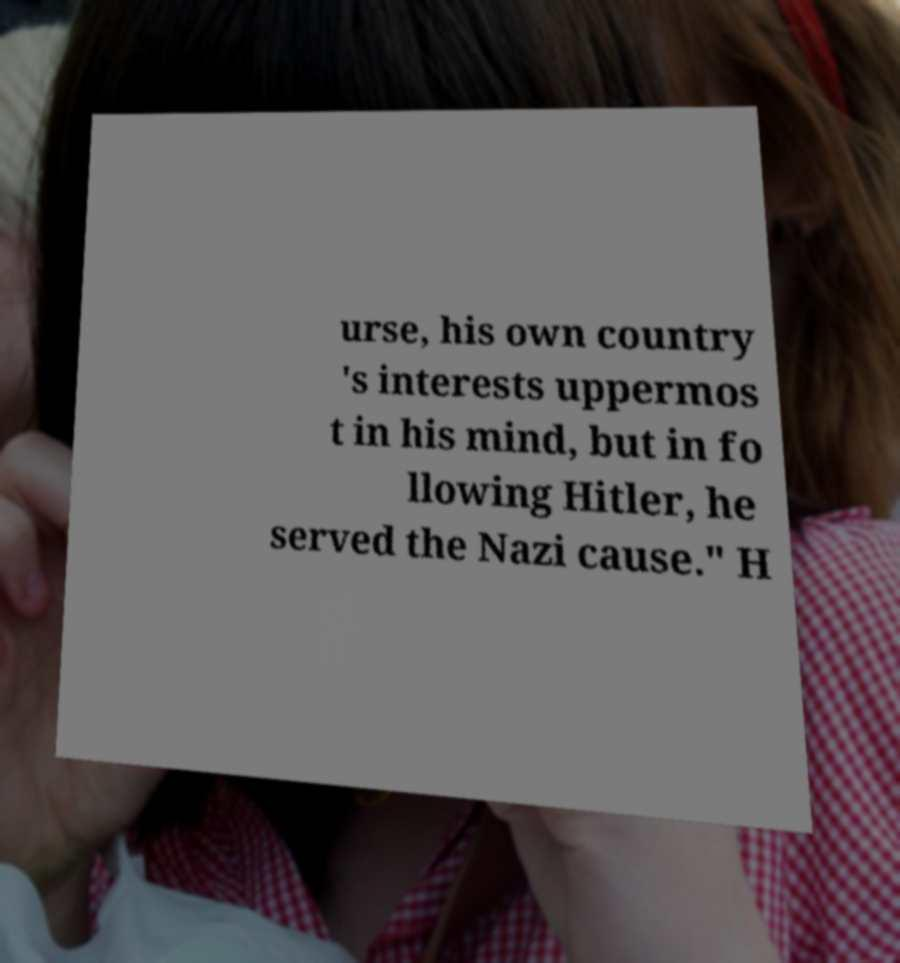For documentation purposes, I need the text within this image transcribed. Could you provide that? urse, his own country 's interests uppermos t in his mind, but in fo llowing Hitler, he served the Nazi cause." H 